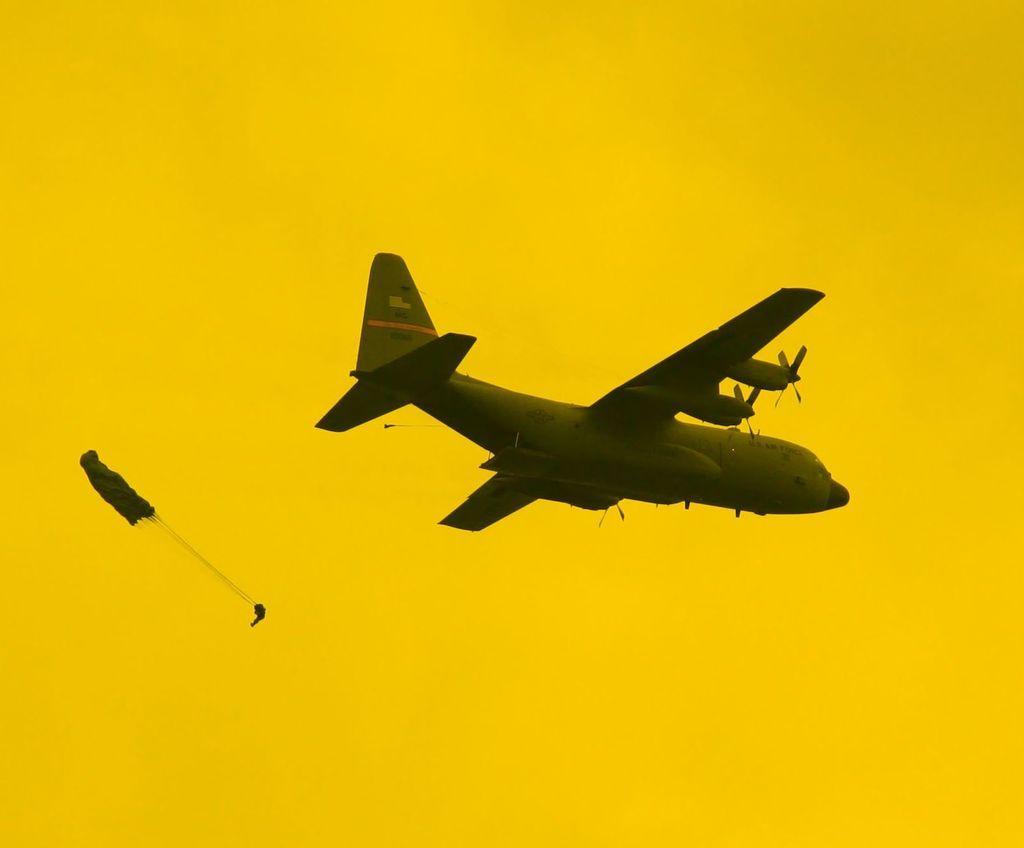Can you describe this image briefly? In this image we can see there is an aeroplane and an object. In the background it is yellow.   